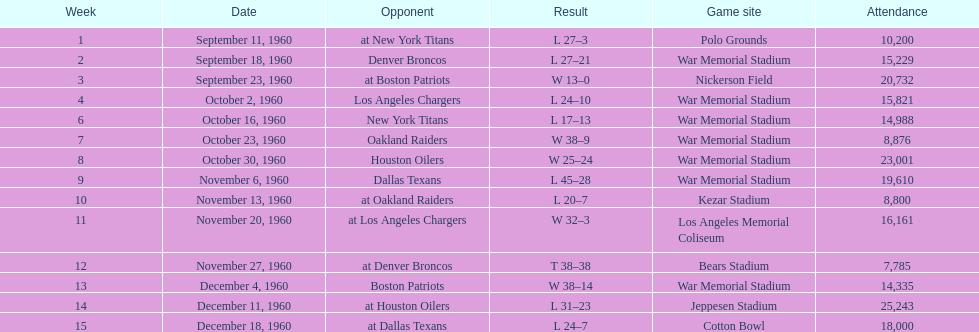How many games were played in total at war memorial stadium? 7. 